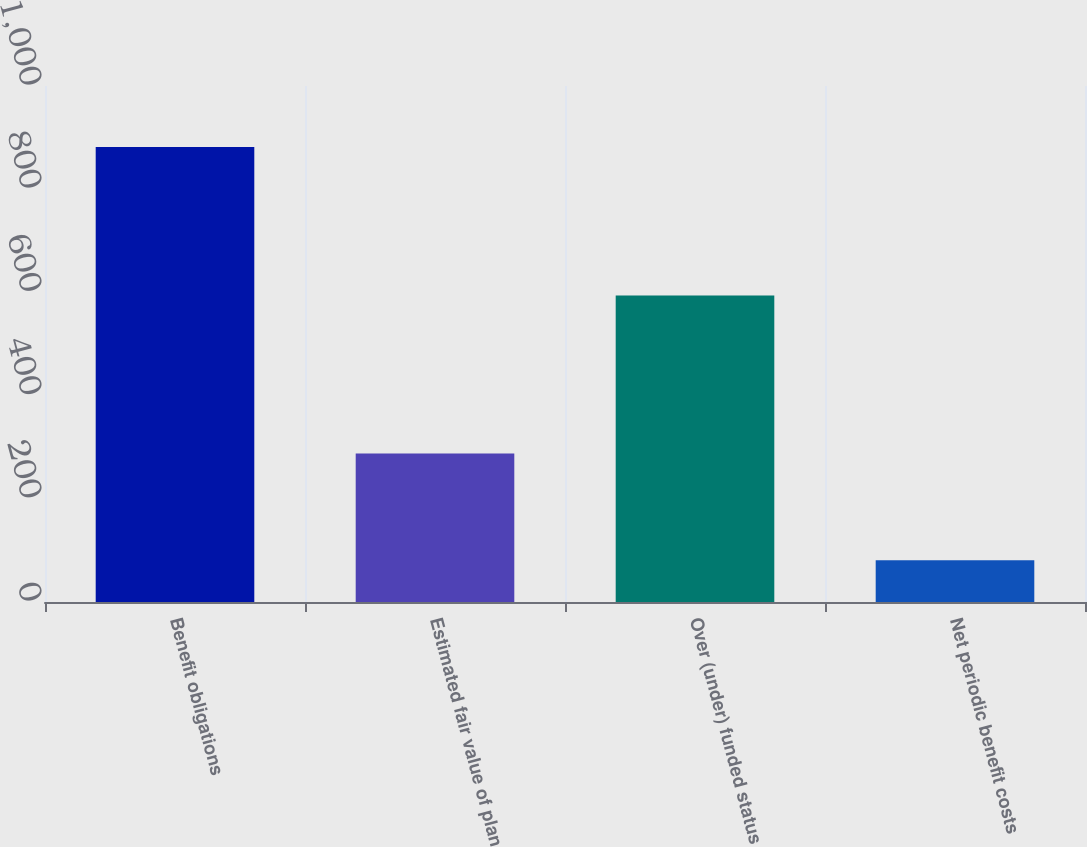<chart> <loc_0><loc_0><loc_500><loc_500><bar_chart><fcel>Benefit obligations<fcel>Estimated fair value of plan<fcel>Over (under) funded status<fcel>Net periodic benefit costs<nl><fcel>882<fcel>288<fcel>594<fcel>81<nl></chart> 